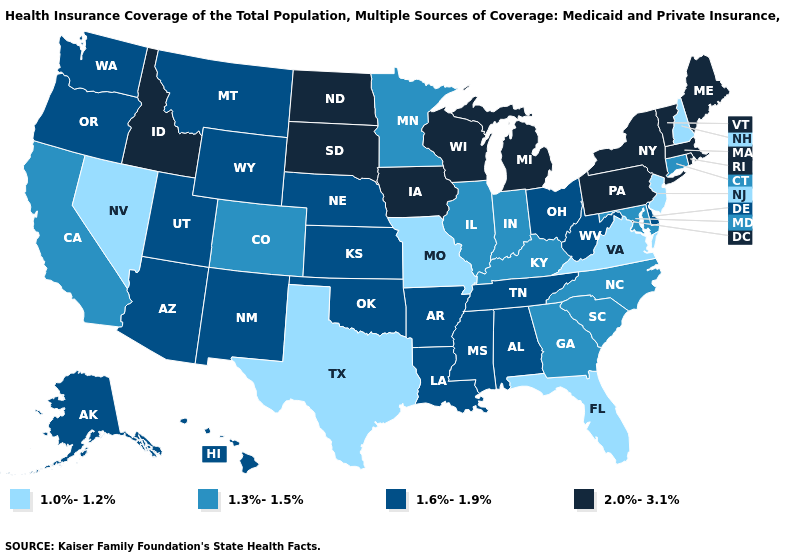What is the lowest value in the MidWest?
Keep it brief. 1.0%-1.2%. What is the value of Louisiana?
Answer briefly. 1.6%-1.9%. What is the value of New Jersey?
Concise answer only. 1.0%-1.2%. Name the states that have a value in the range 2.0%-3.1%?
Answer briefly. Idaho, Iowa, Maine, Massachusetts, Michigan, New York, North Dakota, Pennsylvania, Rhode Island, South Dakota, Vermont, Wisconsin. Does Alabama have the highest value in the USA?
Answer briefly. No. Does South Dakota have the lowest value in the MidWest?
Give a very brief answer. No. Which states have the lowest value in the USA?
Concise answer only. Florida, Missouri, Nevada, New Hampshire, New Jersey, Texas, Virginia. Does Michigan have the same value as Mississippi?
Write a very short answer. No. Does Tennessee have a lower value than Wisconsin?
Be succinct. Yes. What is the lowest value in states that border North Carolina?
Give a very brief answer. 1.0%-1.2%. Name the states that have a value in the range 1.0%-1.2%?
Quick response, please. Florida, Missouri, Nevada, New Hampshire, New Jersey, Texas, Virginia. What is the lowest value in the USA?
Quick response, please. 1.0%-1.2%. Is the legend a continuous bar?
Write a very short answer. No. Does Florida have the lowest value in the USA?
Quick response, please. Yes. Does Minnesota have the lowest value in the USA?
Short answer required. No. 